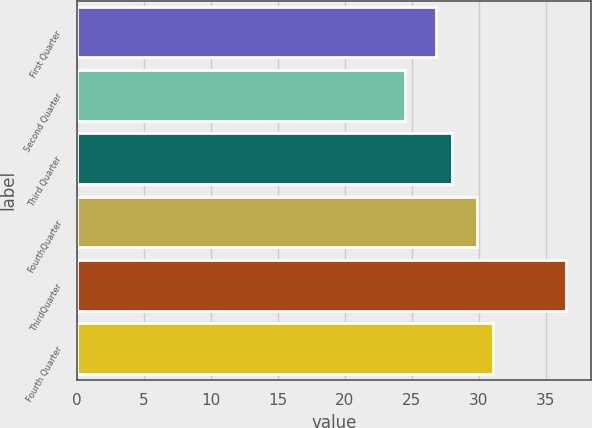Convert chart. <chart><loc_0><loc_0><loc_500><loc_500><bar_chart><fcel>First Quarter<fcel>Second Quarter<fcel>Third Quarter<fcel>FourthQuarter<fcel>ThirdQuarter<fcel>Fourth Quarter<nl><fcel>26.81<fcel>24.45<fcel>28.02<fcel>29.82<fcel>36.52<fcel>31.03<nl></chart> 